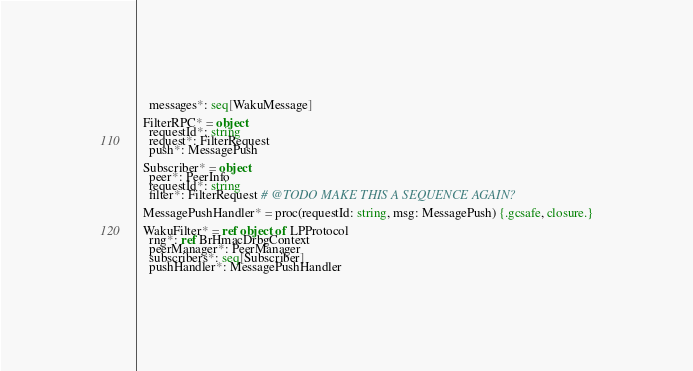Convert code to text. <code><loc_0><loc_0><loc_500><loc_500><_Nim_>    messages*: seq[WakuMessage]

  FilterRPC* = object
    requestId*: string
    request*: FilterRequest
    push*: MessagePush

  Subscriber* = object
    peer*: PeerInfo
    requestId*: string
    filter*: FilterRequest # @TODO MAKE THIS A SEQUENCE AGAIN?

  MessagePushHandler* = proc(requestId: string, msg: MessagePush) {.gcsafe, closure.}

  WakuFilter* = ref object of LPProtocol
    rng*: ref BrHmacDrbgContext
    peerManager*: PeerManager
    subscribers*: seq[Subscriber]
    pushHandler*: MessagePushHandler
</code> 